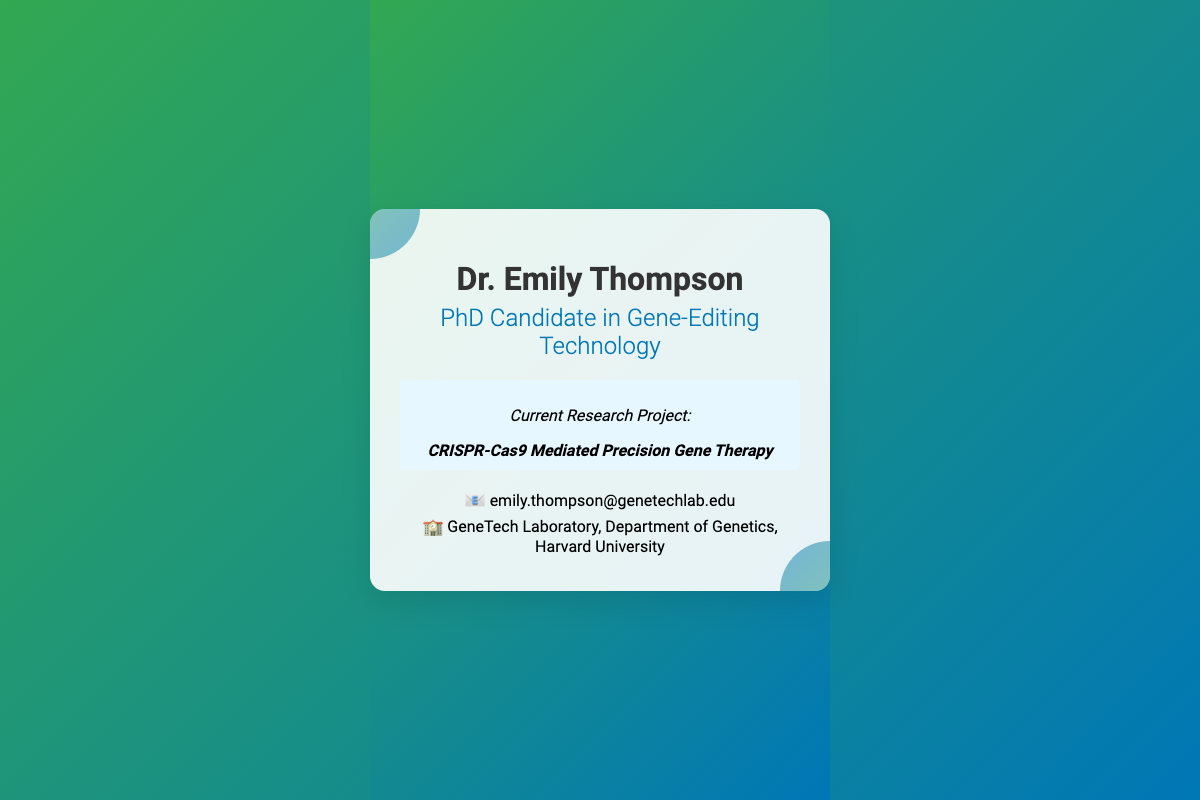What is the full name of the PhD candidate? The document states the full name at the top, which is "Dr. Emily Thompson."
Answer: Dr. Emily Thompson What is the title of the PhD candidate? The document provides the title beneath the name, specifying: "PhD Candidate in Gene-Editing Technology."
Answer: PhD Candidate in Gene-Editing Technology What is the current research project? The project is detailed in the middle section of the card, indicating: "CRISPR-Cas9 Mediated Precision Gene Therapy."
Answer: CRISPR-Cas9 Mediated Precision Gene Therapy What is the email address listed on the card? The email address can be found in the contact information section, which states: "emily.thompson@genetechlab.edu."
Answer: emily.thompson@genetechlab.edu What is the affiliation of the lab? The lab affiliation is detailed towards the end of the document, indicating: "GeneTech Laboratory, Department of Genetics, Harvard University."
Answer: GeneTech Laboratory, Department of Genetics, Harvard University What colors are used in the background gradient? The gradient colors in the background are mentioned within the style section as being green and blue.
Answer: Green and blue What does the card signify with its color scheme? The use of green and blue in the gradient is intended to represent concepts of innovation and growth, as noted in the design.
Answer: Innovation and growth What type of document is this? The document is designed as a business card, indicated by its format and content emphasis.
Answer: Business card 